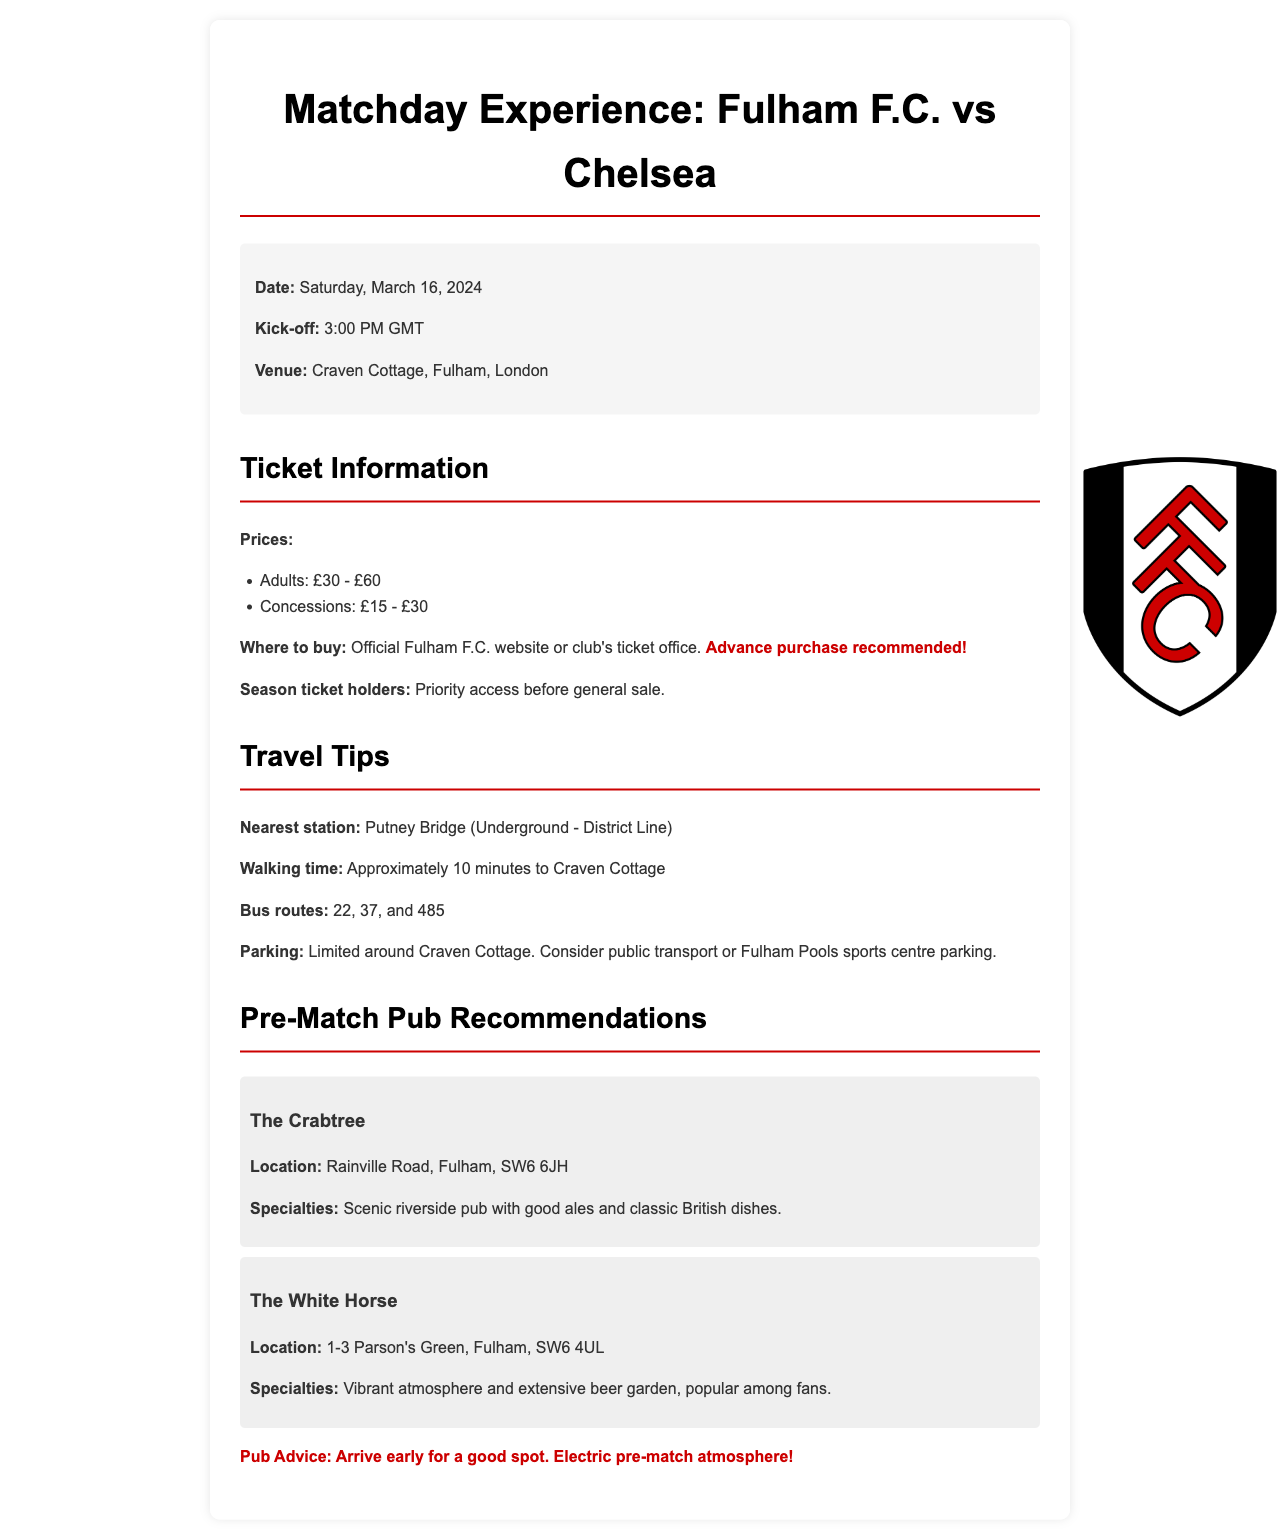What is the match date? The match date is clearly stated in the document under the match information section.
Answer: Saturday, March 16, 2024 What time does the match kick off? The kick-off time is mentioned alongside the match date in the match information.
Answer: 3:00 PM GMT What is the location of the nearest station? The nearest station is specified in the travel tips section.
Answer: Putney Bridge What are the adult ticket prices? Ticket prices are detailed in the ticket information section and separated into categories.
Answer: £30 - £60 Where can tickets be purchased? The document specifies where to buy tickets in the ticket information section.
Answer: Official Fulham F.C. website or club's ticket office Which pub is described as having a scenic riverside view? The pubs are listed in the pre-match pub recommendations and details about them are provided.
Answer: The Crabtree What should fans do for a good spot in the pub? The document provides advice related to arriving early for pubs.
Answer: Arrive early What is the walking time from the nearest station to the venue? The walking time is mentioned in the travel tips, providing a quick reference for fans.
Answer: Approximately 10 minutes What type of atmosphere does The White Horse pub offer? This is outlined in the descriptions of the pubs, highlighting their unique features.
Answer: Vibrant atmosphere 